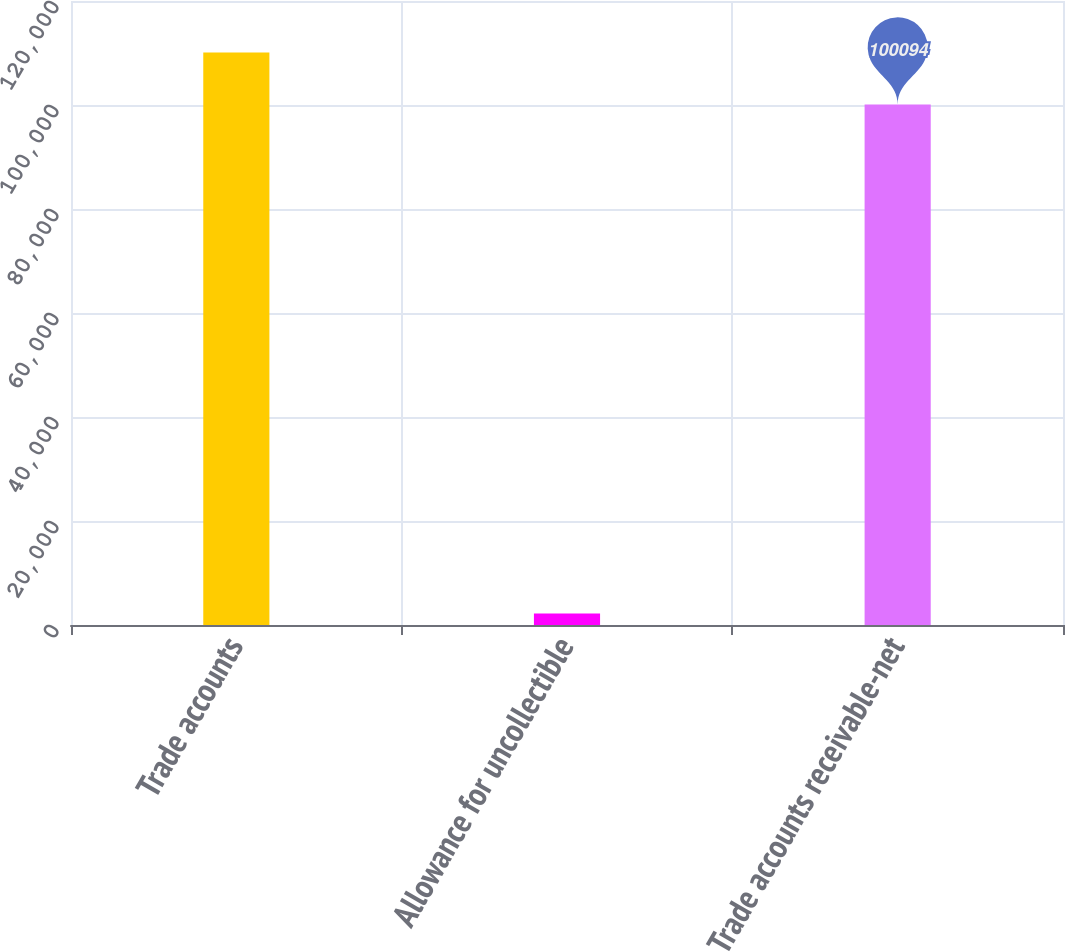Convert chart. <chart><loc_0><loc_0><loc_500><loc_500><bar_chart><fcel>Trade accounts<fcel>Allowance for uncollectible<fcel>Trade accounts receivable-net<nl><fcel>110103<fcel>2223<fcel>100094<nl></chart> 